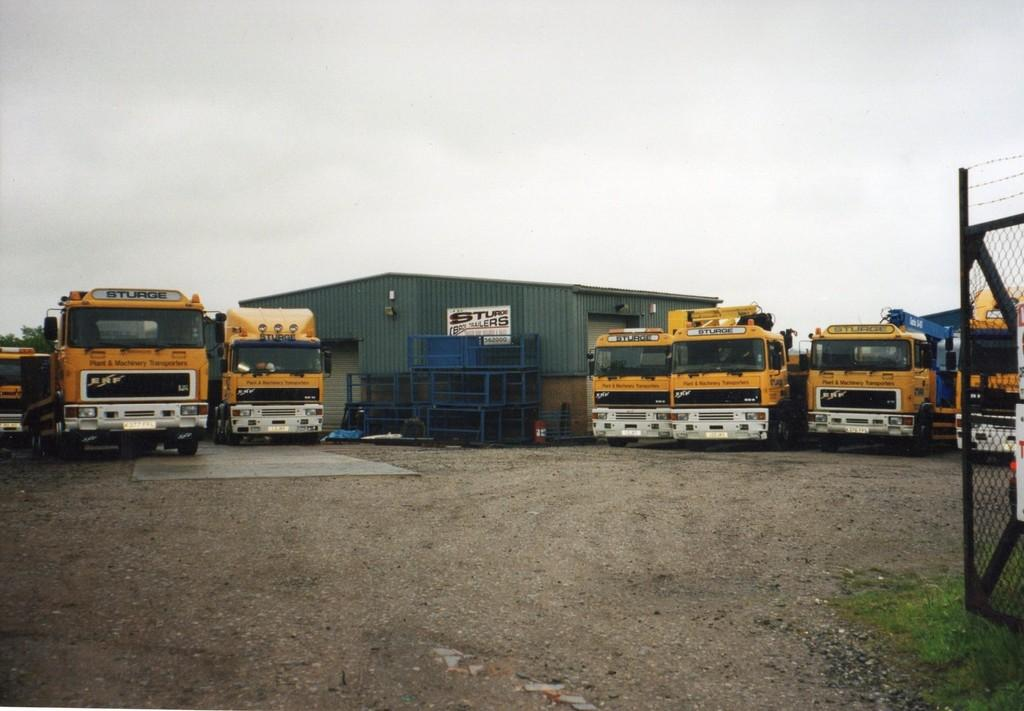What type of terrain is visible in the front of the image? There is land in the front of the image. What can be seen on the right side of the image? There is a fence on the right side of the image. What vehicles are present at the back of the image? There are trucks at the back of the image. What structure is located in the center of the image? There is a shed in the center of the image. What is visible at the top of the image? The sky is visible at the top of the image. Can you touch the lizards that are crawling on the shed in the image? There are no lizards present in the image; only land, a fence, trucks, a shed, and the sky are visible. 